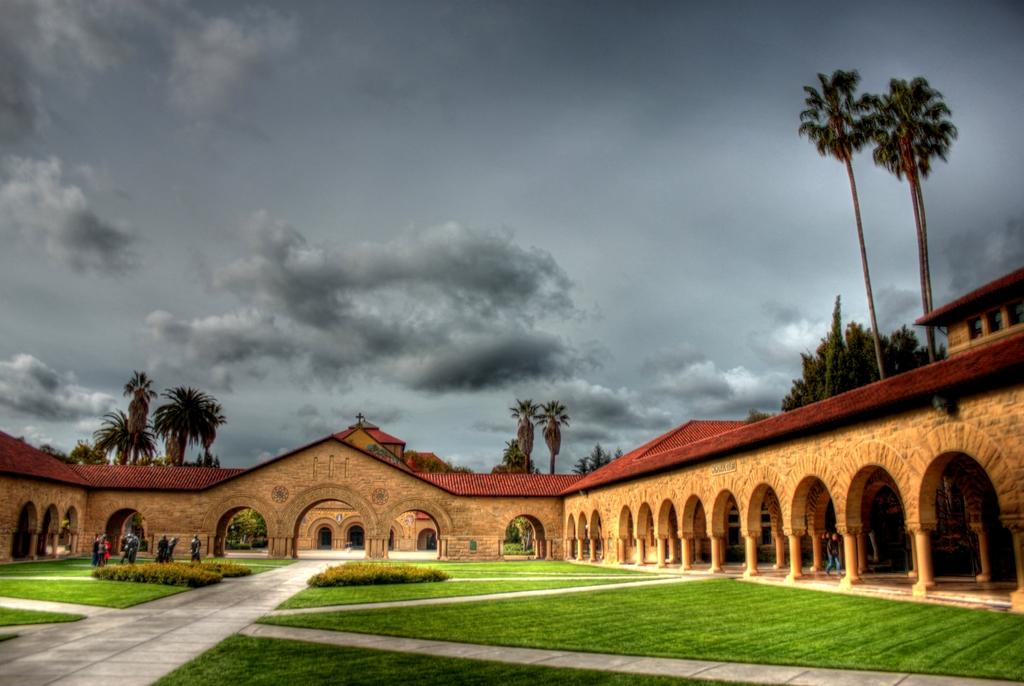What type of structures can be seen in the image? There are buildings in the image. What type of vegetation is present in the image? There are trees and shrubs in the image. Are there any living beings visible in the image? Yes, there are people in the image. What can be seen in the background of the image? The sky is visible in the background of the image. How many kittens are sitting on the sink in the image? There is no sink or kittens present in the image. What thought is the person in the image having? The image does not provide information about the thoughts of the people in the image. 